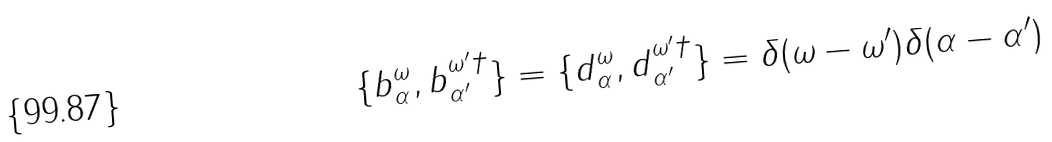Convert formula to latex. <formula><loc_0><loc_0><loc_500><loc_500>\{ b _ { \alpha } ^ { \omega } , b _ { \alpha ^ { \prime } } ^ { \omega ^ { \prime } \dagger } \} = \{ d _ { \alpha } ^ { \omega } , d _ { \alpha ^ { \prime } } ^ { \omega ^ { \prime } \dagger } \} = \delta ( \omega - \omega ^ { \prime } ) \delta ( \alpha - \alpha ^ { \prime } )</formula> 